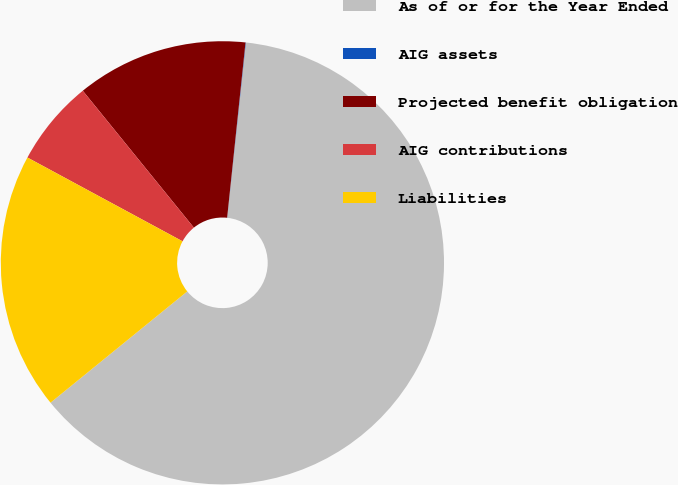Convert chart to OTSL. <chart><loc_0><loc_0><loc_500><loc_500><pie_chart><fcel>As of or for the Year Ended<fcel>AIG assets<fcel>Projected benefit obligation<fcel>AIG contributions<fcel>Liabilities<nl><fcel>62.43%<fcel>0.03%<fcel>12.51%<fcel>6.27%<fcel>18.75%<nl></chart> 